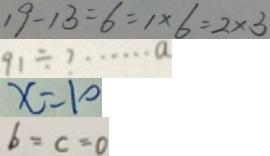Convert formula to latex. <formula><loc_0><loc_0><loc_500><loc_500>1 9 - 1 3 = 6 = 1 \times 6 = 2 \times 3 
 9 1 \div ? \cdots a 
 x = 1 0 
 b = c = 0</formula> 